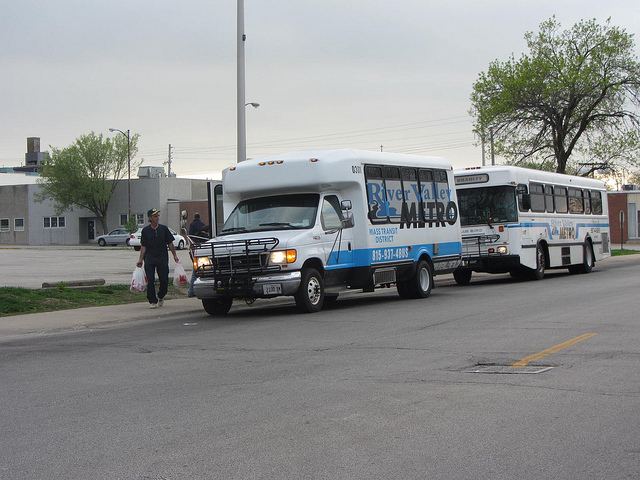<image>What four letter word is on the side of the bus? It is ambiguous. The four letter word on the side of the bus can be 'mass', 'metro', 'stop', or 'miro'. What four letter word is on the side of the bus? I don't know what four letter word is on the side of the bus. It can be 'mass', 'metro', 'stop', or 'miro'. 